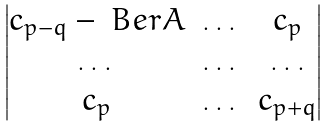<formula> <loc_0><loc_0><loc_500><loc_500>\begin{vmatrix} c _ { p - q } - \ B e r A & \dots & c _ { p } \\ \dots & \dots & \dots \\ c _ { p } & \dots & c _ { p + q } \\ \end{vmatrix}</formula> 